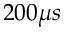Convert formula to latex. <formula><loc_0><loc_0><loc_500><loc_500>2 0 0 \mu s</formula> 